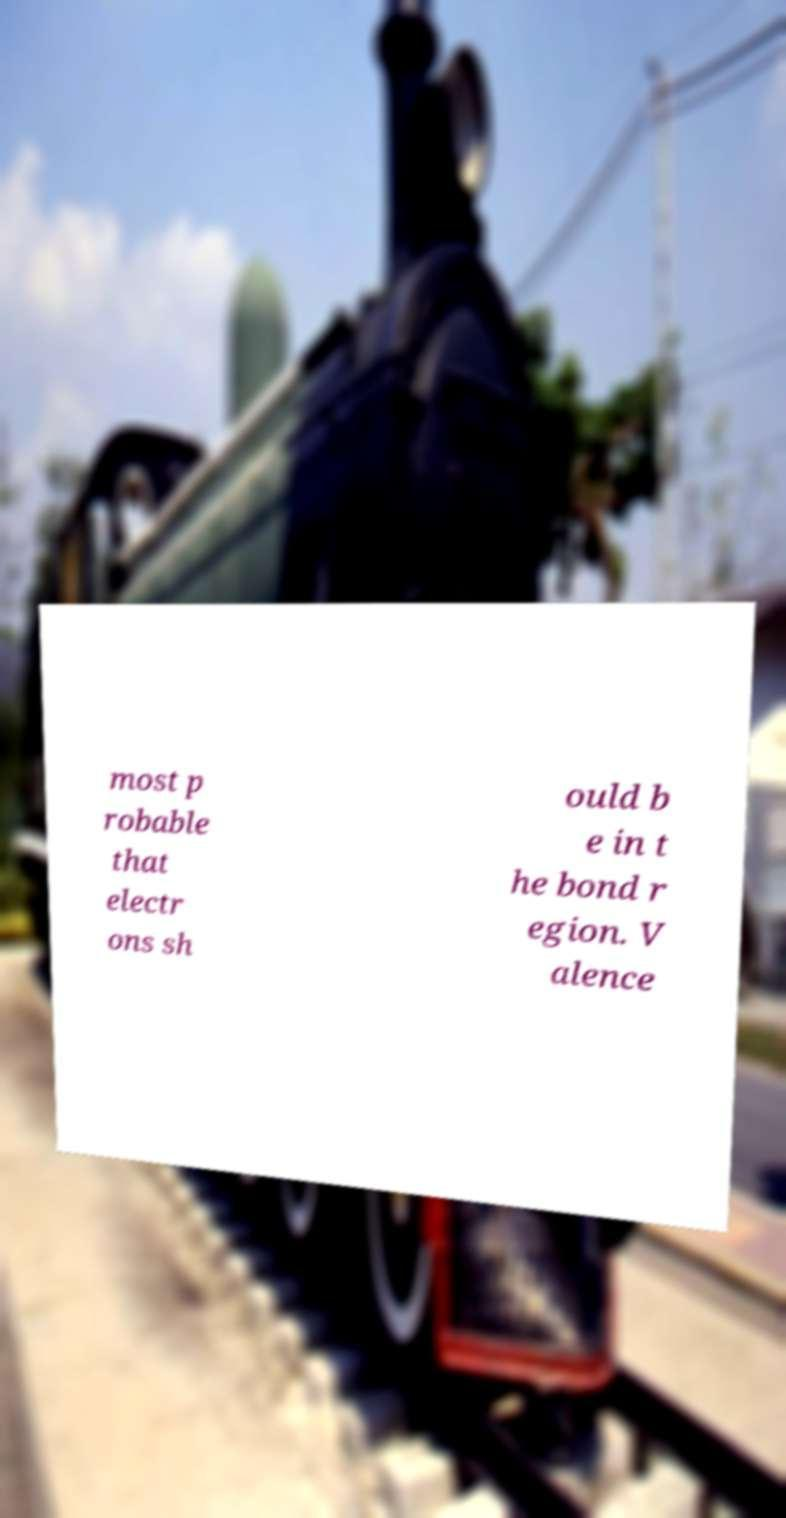Could you extract and type out the text from this image? most p robable that electr ons sh ould b e in t he bond r egion. V alence 